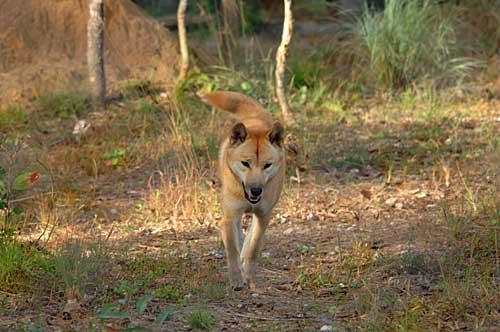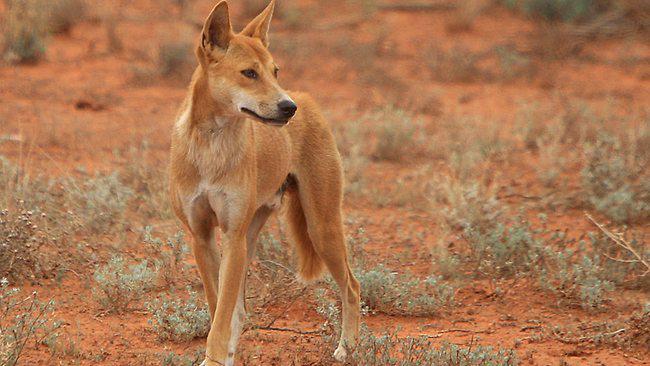The first image is the image on the left, the second image is the image on the right. Evaluate the accuracy of this statement regarding the images: "Each picture has 1 dog". Is it true? Answer yes or no. Yes. The first image is the image on the left, the second image is the image on the right. Considering the images on both sides, is "The image on the left shows two animals." valid? Answer yes or no. No. 